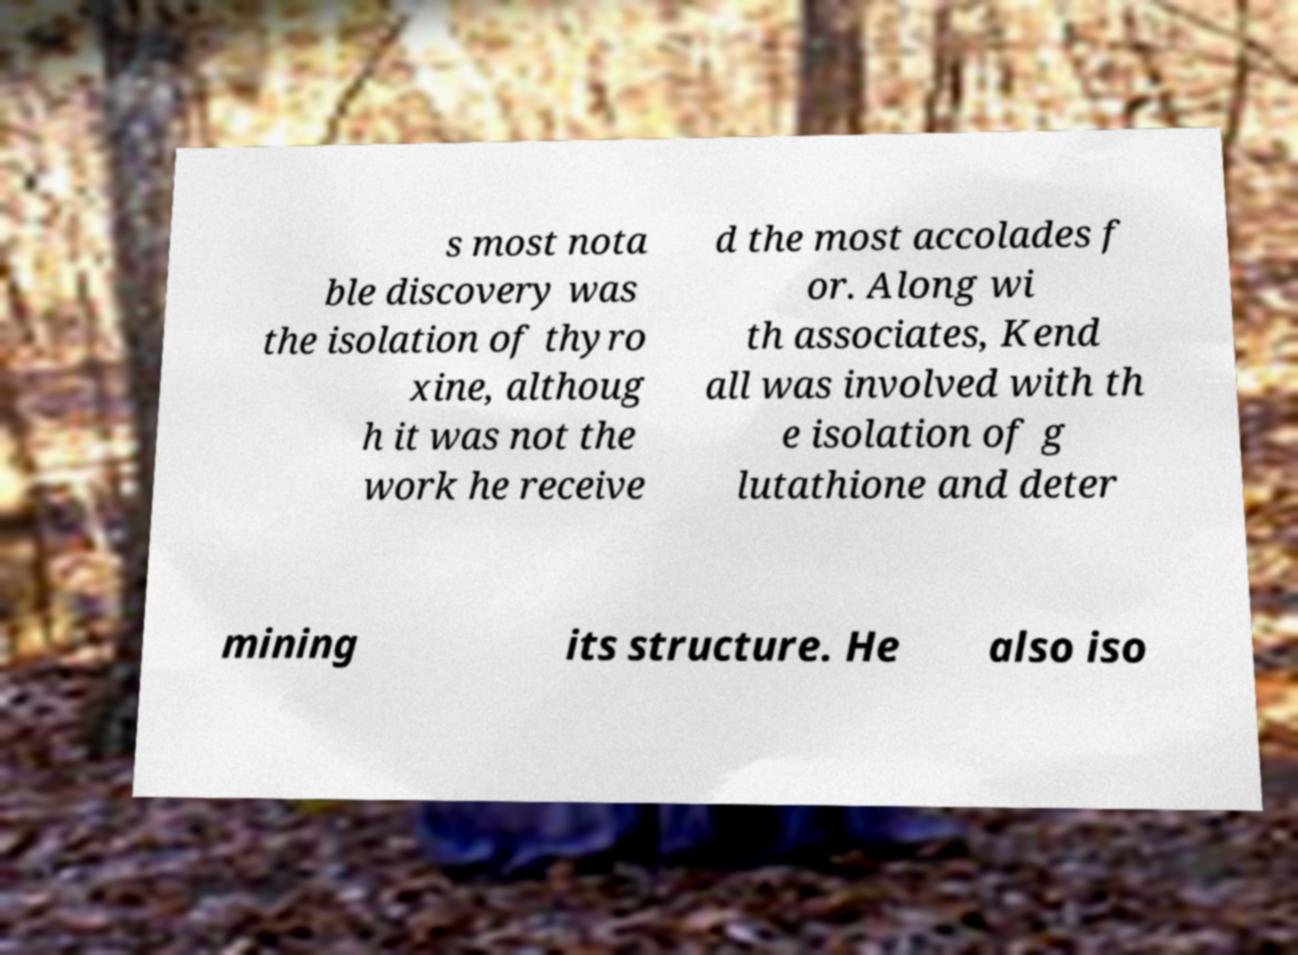Can you accurately transcribe the text from the provided image for me? s most nota ble discovery was the isolation of thyro xine, althoug h it was not the work he receive d the most accolades f or. Along wi th associates, Kend all was involved with th e isolation of g lutathione and deter mining its structure. He also iso 